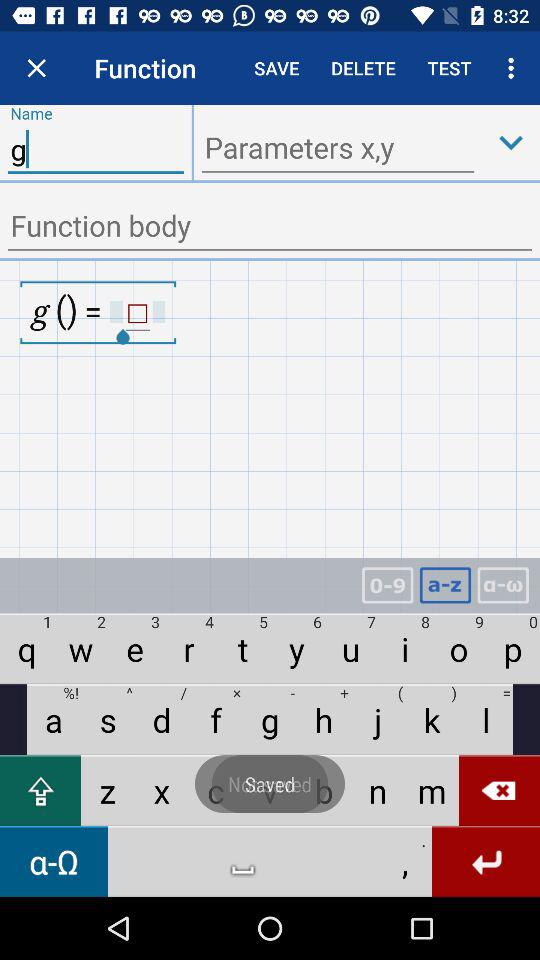What is the function body?
When the provided information is insufficient, respond with <no answer>. <no answer> 